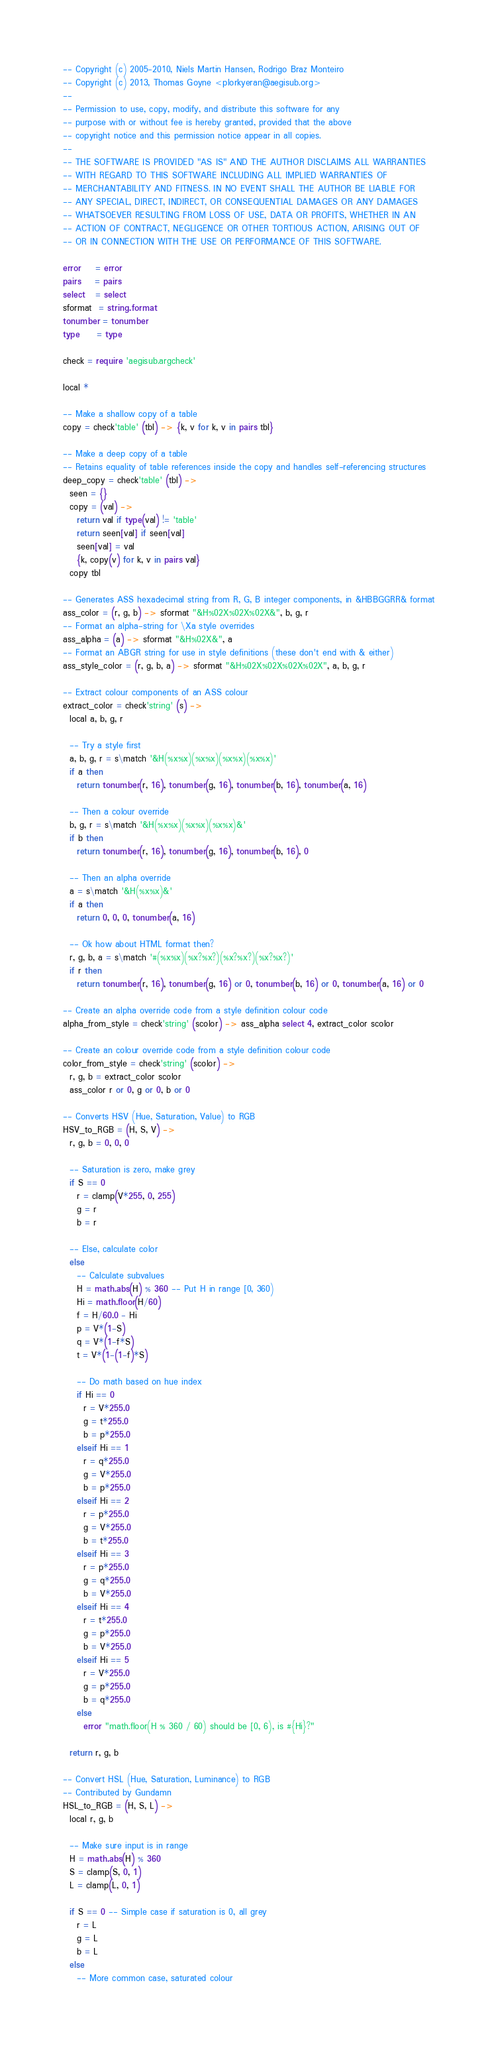<code> <loc_0><loc_0><loc_500><loc_500><_MoonScript_>-- Copyright (c) 2005-2010, Niels Martin Hansen, Rodrigo Braz Monteiro
-- Copyright (c) 2013, Thomas Goyne <plorkyeran@aegisub.org>
--
-- Permission to use, copy, modify, and distribute this software for any
-- purpose with or without fee is hereby granted, provided that the above
-- copyright notice and this permission notice appear in all copies.
--
-- THE SOFTWARE IS PROVIDED "AS IS" AND THE AUTHOR DISCLAIMS ALL WARRANTIES
-- WITH REGARD TO THIS SOFTWARE INCLUDING ALL IMPLIED WARRANTIES OF
-- MERCHANTABILITY AND FITNESS. IN NO EVENT SHALL THE AUTHOR BE LIABLE FOR
-- ANY SPECIAL, DIRECT, INDIRECT, OR CONSEQUENTIAL DAMAGES OR ANY DAMAGES
-- WHATSOEVER RESULTING FROM LOSS OF USE, DATA OR PROFITS, WHETHER IN AN
-- ACTION OF CONTRACT, NEGLIGENCE OR OTHER TORTIOUS ACTION, ARISING OUT OF
-- OR IN CONNECTION WITH THE USE OR PERFORMANCE OF THIS SOFTWARE.

error    = error
pairs    = pairs
select   = select
sformat  = string.format
tonumber = tonumber
type     = type

check = require 'aegisub.argcheck'

local *

-- Make a shallow copy of a table
copy = check'table' (tbl) -> {k, v for k, v in pairs tbl}

-- Make a deep copy of a table
-- Retains equality of table references inside the copy and handles self-referencing structures
deep_copy = check'table' (tbl) ->
  seen = {}
  copy = (val) ->
    return val if type(val) != 'table'
    return seen[val] if seen[val]
    seen[val] = val
    {k, copy(v) for k, v in pairs val}
  copy tbl

-- Generates ASS hexadecimal string from R, G, B integer components, in &HBBGGRR& format
ass_color = (r, g, b) -> sformat "&H%02X%02X%02X&", b, g, r
-- Format an alpha-string for \Xa style overrides
ass_alpha = (a) -> sformat "&H%02X&", a
-- Format an ABGR string for use in style definitions (these don't end with & either)
ass_style_color = (r, g, b, a) -> sformat "&H%02X%02X%02X%02X", a, b, g, r

-- Extract colour components of an ASS colour
extract_color = check'string' (s) ->
  local a, b, g, r

  -- Try a style first
  a, b, g, r = s\match '&H(%x%x)(%x%x)(%x%x)(%x%x)'
  if a then
    return tonumber(r, 16), tonumber(g, 16), tonumber(b, 16), tonumber(a, 16)

  -- Then a colour override
  b, g, r = s\match '&H(%x%x)(%x%x)(%x%x)&'
  if b then
    return tonumber(r, 16), tonumber(g, 16), tonumber(b, 16), 0

  -- Then an alpha override
  a = s\match '&H(%x%x)&'
  if a then
    return 0, 0, 0, tonumber(a, 16)

  -- Ok how about HTML format then?
  r, g, b, a = s\match '#(%x%x)(%x?%x?)(%x?%x?)(%x?%x?)'
  if r then
    return tonumber(r, 16), tonumber(g, 16) or 0, tonumber(b, 16) or 0, tonumber(a, 16) or 0

-- Create an alpha override code from a style definition colour code
alpha_from_style = check'string' (scolor) -> ass_alpha select 4, extract_color scolor

-- Create an colour override code from a style definition colour code
color_from_style = check'string' (scolor) ->
  r, g, b = extract_color scolor
  ass_color r or 0, g or 0, b or 0

-- Converts HSV (Hue, Saturation, Value) to RGB
HSV_to_RGB = (H, S, V) ->
  r, g, b = 0, 0, 0

  -- Saturation is zero, make grey
  if S == 0
    r = clamp(V*255, 0, 255)
    g = r
    b = r

  -- Else, calculate color
  else
    -- Calculate subvalues
    H = math.abs(H) % 360 -- Put H in range [0, 360)
    Hi = math.floor(H/60)
    f = H/60.0 - Hi
    p = V*(1-S)
    q = V*(1-f*S)
    t = V*(1-(1-f)*S)

    -- Do math based on hue index
    if Hi == 0
      r = V*255.0
      g = t*255.0
      b = p*255.0
    elseif Hi == 1
      r = q*255.0
      g = V*255.0
      b = p*255.0
    elseif Hi == 2
      r = p*255.0
      g = V*255.0
      b = t*255.0
    elseif Hi == 3
      r = p*255.0
      g = q*255.0
      b = V*255.0
    elseif Hi == 4
      r = t*255.0
      g = p*255.0
      b = V*255.0
    elseif Hi == 5
      r = V*255.0
      g = p*255.0
      b = q*255.0
    else
      error "math.floor(H % 360 / 60) should be [0, 6), is #{Hi}?"

  return r, g, b

-- Convert HSL (Hue, Saturation, Luminance) to RGB
-- Contributed by Gundamn
HSL_to_RGB = (H, S, L) ->
  local r, g, b

  -- Make sure input is in range
  H = math.abs(H) % 360
  S = clamp(S, 0, 1)
  L = clamp(L, 0, 1)

  if S == 0 -- Simple case if saturation is 0, all grey
    r = L
    g = L
    b = L
  else
    -- More common case, saturated colour</code> 